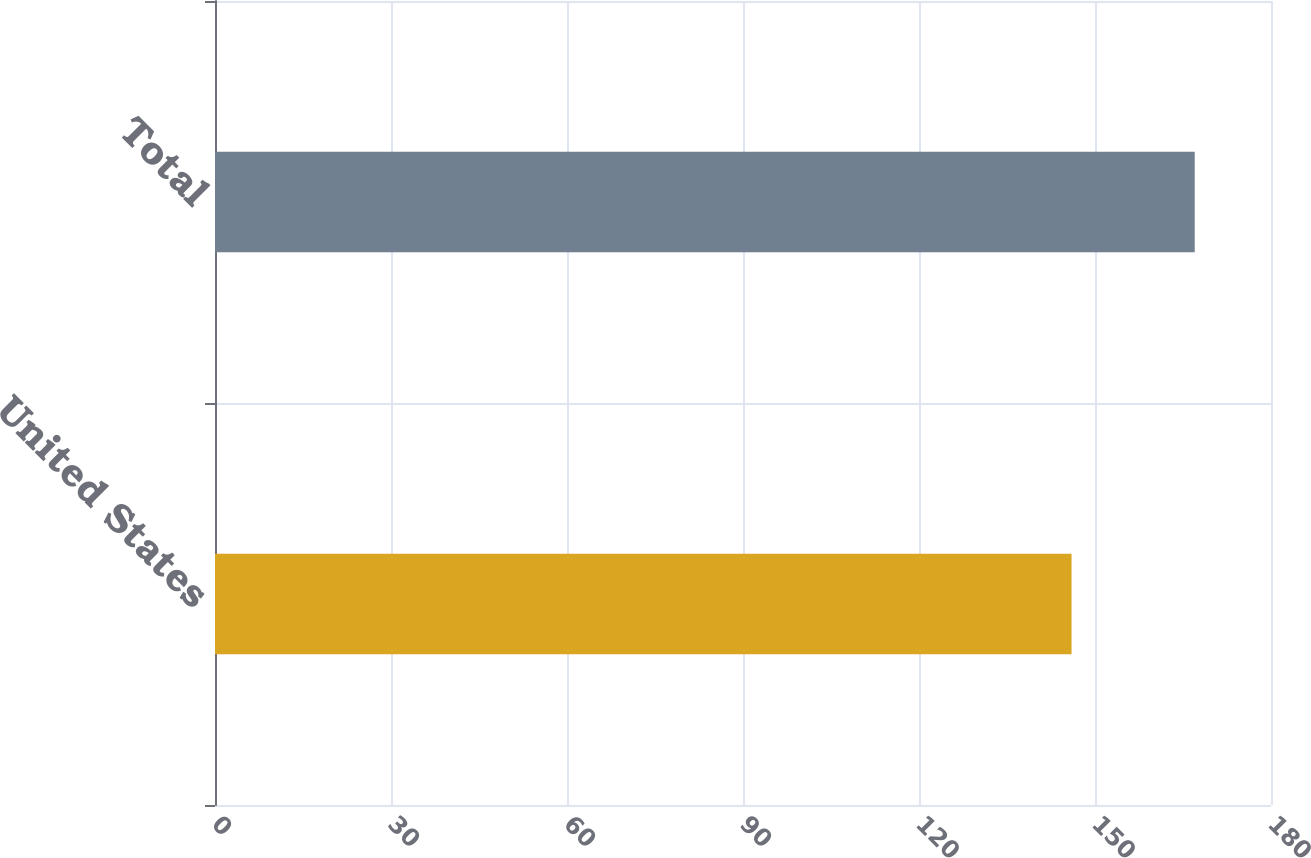Convert chart. <chart><loc_0><loc_0><loc_500><loc_500><bar_chart><fcel>United States<fcel>Total<nl><fcel>146<fcel>167<nl></chart> 